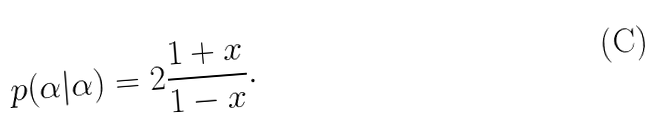Convert formula to latex. <formula><loc_0><loc_0><loc_500><loc_500>p ( \alpha | \alpha ) = 2 \frac { 1 + x } { 1 - x } .</formula> 